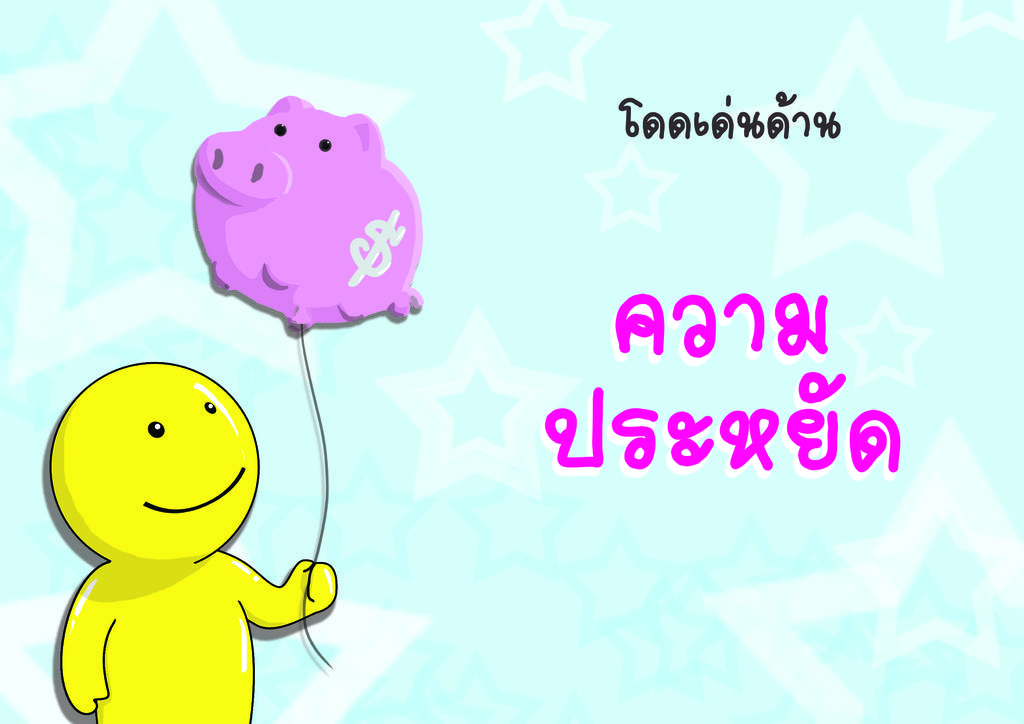What color is the toy in the image? The toy in the image is yellow. What is the toy holding in the image? The toy is holding a pink color balloon. What can be seen in addition to the toy and balloon in the image? There is text visible in the image. What color is the background of the image? The background of the image is blue. Can you see a badge on the toy in the image? There is no badge visible on the toy in the image. Is the toy attacking anyone in the image? There is no indication of the toy attacking anyone in the image. 